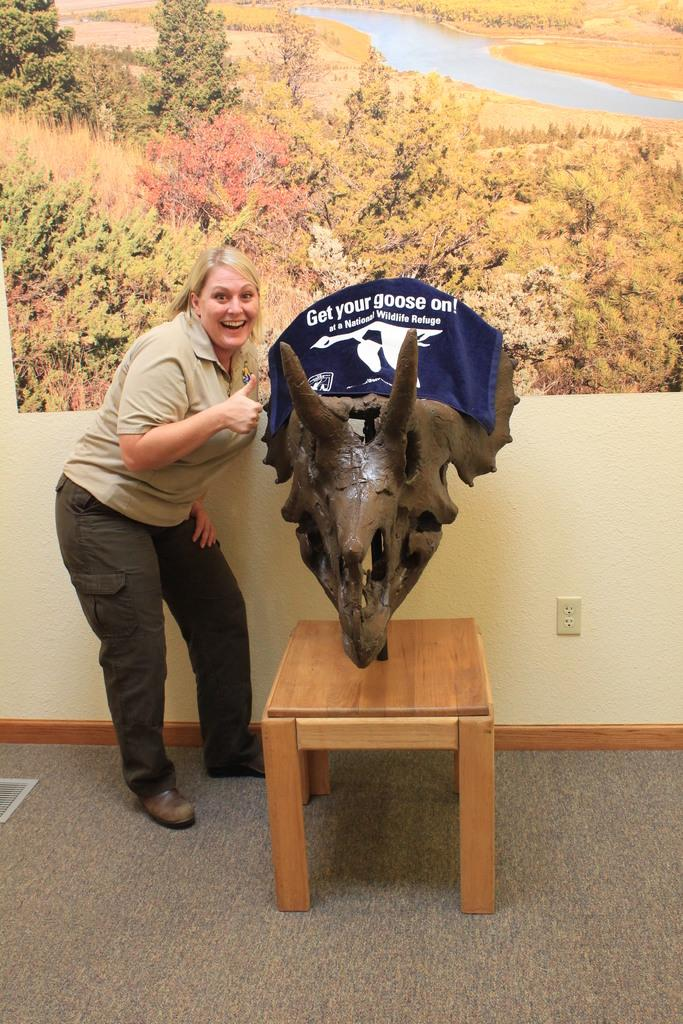Who is present in the image? There is a woman in the image. What is the woman doing in the image? The woman is standing and smiling. What type of object can be seen in the image? There is a deer horn sculpture in the image. Where is the deer horn sculpture located? The deer horn sculpture is placed in a chair. What can be seen in the background of the image? There is a wall poster, a wall, and a carpet in the background of the image. How does the woman plan to attack the deer horn sculpture in the image? There is no indication in the image that the woman plans to attack the deer horn sculpture, nor is there any evidence of an attack. 